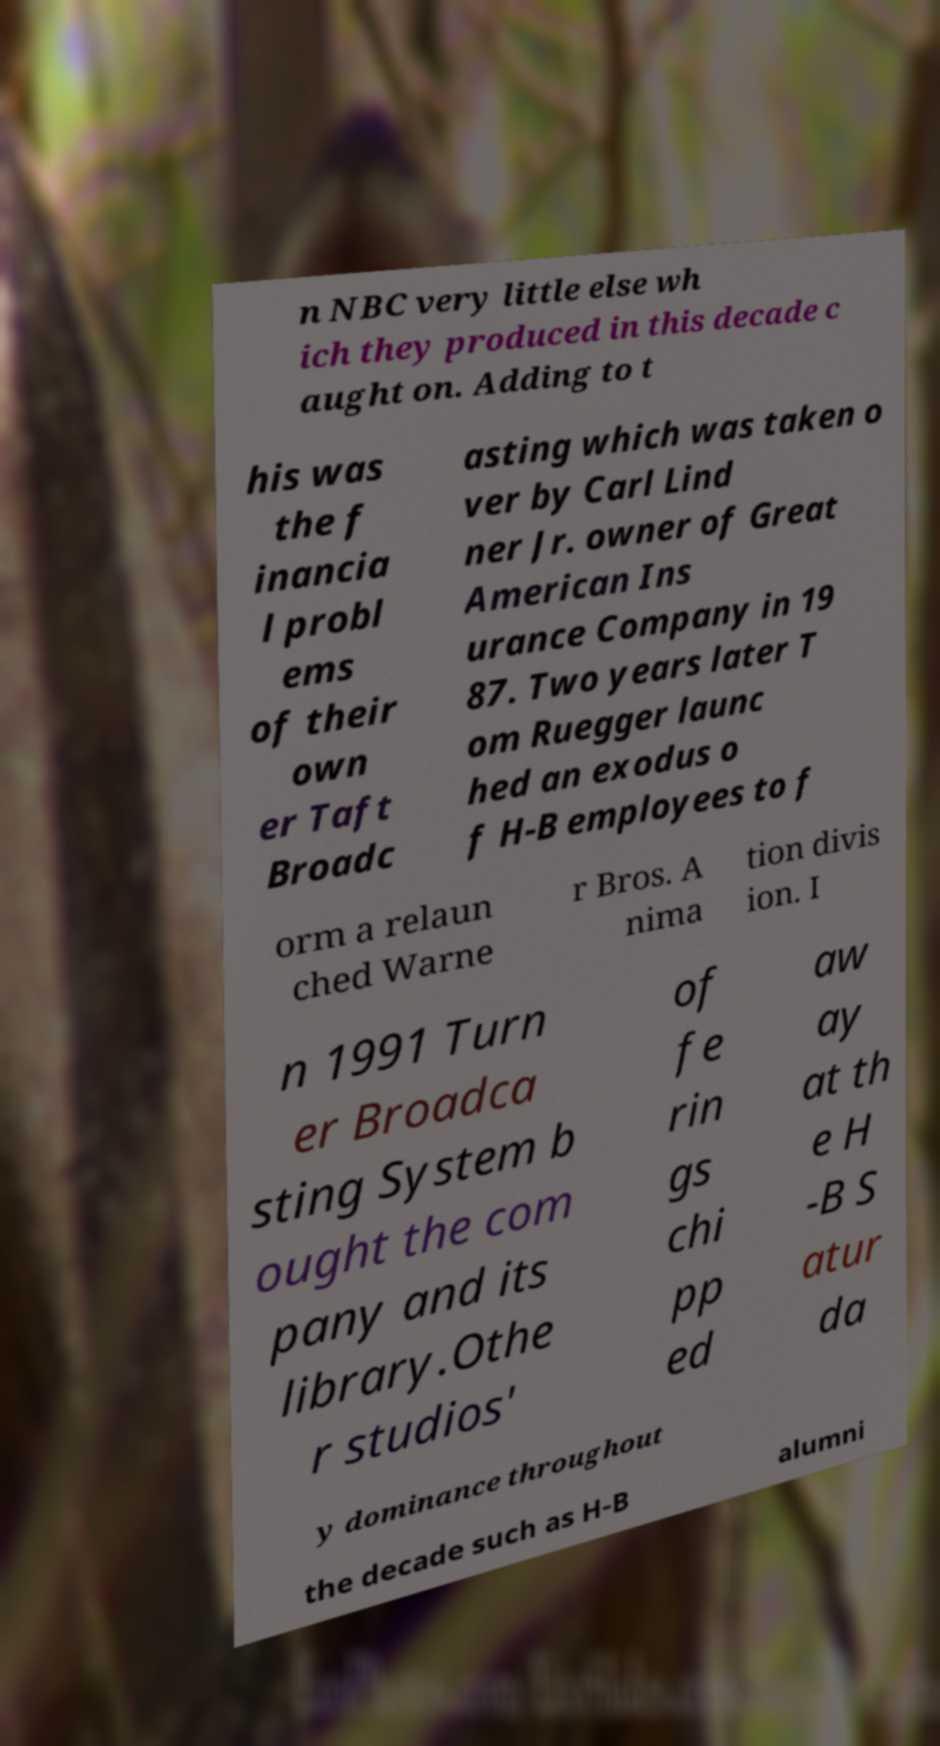Can you read and provide the text displayed in the image?This photo seems to have some interesting text. Can you extract and type it out for me? n NBC very little else wh ich they produced in this decade c aught on. Adding to t his was the f inancia l probl ems of their own er Taft Broadc asting which was taken o ver by Carl Lind ner Jr. owner of Great American Ins urance Company in 19 87. Two years later T om Ruegger launc hed an exodus o f H-B employees to f orm a relaun ched Warne r Bros. A nima tion divis ion. I n 1991 Turn er Broadca sting System b ought the com pany and its library.Othe r studios' of fe rin gs chi pp ed aw ay at th e H -B S atur da y dominance throughout the decade such as H-B alumni 